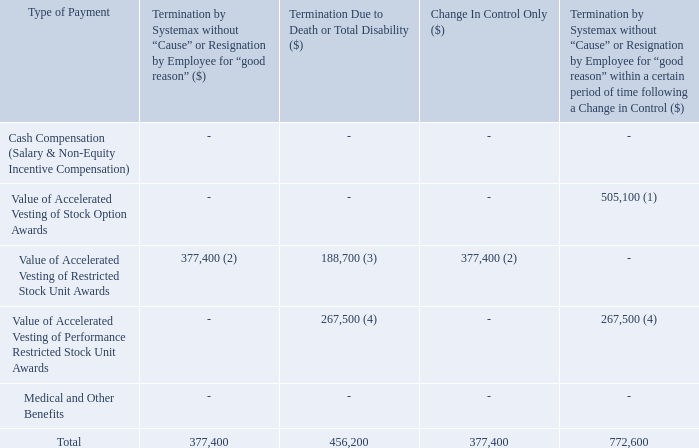(1) Represents accelerated vesting of 48,849 stock options. Pursuant to Mr. Dooley’s stock option agreements (dated January 17, 2019),
if Mr. Dooley’s employment is terminated without cause or for good reason within six months following a “change in control”, he will
become immediately vested in all outstanding unvested stock options, and all of Mr. Dooley’s outstanding options shall remain
exercisable in accordance with their terms, but in no event for less than 90 days after such termination.
(2) Represents accelerated vesting of 15,000 unvested restricted stock units. Pursuant to Mr. Dooley’s restricted stock unit agreement
(dated March 1, 2012), upon a “change in control” all non-vested units shall accelerate and be vested as of the date of the “change in
control” and if Mr. Dooley’s employment is terminated without cause or for good reason, all non-vested units shall accelerate and be
vested as of the date of termination
(3) Represents accelerated vesting of 7,500 unvested restricted stock units. Pursuant to Mr. Dooley’s restricted stock unit agreement
(dated March 1, 2012), on the event of Mr. Dooley’s death or total disability, 7,500 restricted stock units (50% of the unvested restricted
stock units granted under such agreement at December 31, 2018) would vest.
(4) Represents accelerated vesting of 10,630 unvested performance restricted stock units. Pursuant to Mr. Dooley's performance restricted
stock unit agreement (dated January 17, 2019), if Mr. Dooley’s employment is terminated without cause or for good reason within six
months following a “change in control” or if Mr. Dooley's employment is terminated due to death or total disability, all non-vested units
shall accelerate and be vested as of the date of termination.
What are the accelerated vesting of Robert Dooley's unvested restricted stock units for change in control only or termination due to death respectively?  15,000, 7,500. What are the accelerated vesting of Robert Dooley's stock options for termination by Systemax without "Cause" or unvested performance restricted stock units for termination due to death respectively? 48,849, 10,630. What is Robert Dooley's total payment due to change in control only? 377,400. What are the accelerated vesting of Robert Dooley's unvested restricted stock units for termination by Systemax without "cause" or termination due to death?  15,000 + 7,500 
Answer: 22500. What is the total accelerated vesting of Robert Dooley's stock options and unvested performance restricted stock units? 48,849 + 10,630 
Answer: 59479. What is the percentage of payment due as a result of change in control as a percentage of the payment due to termination without cause within a certain period following a change in control?
Answer scale should be: percent. 377,400/772,600 
Answer: 48.85. 